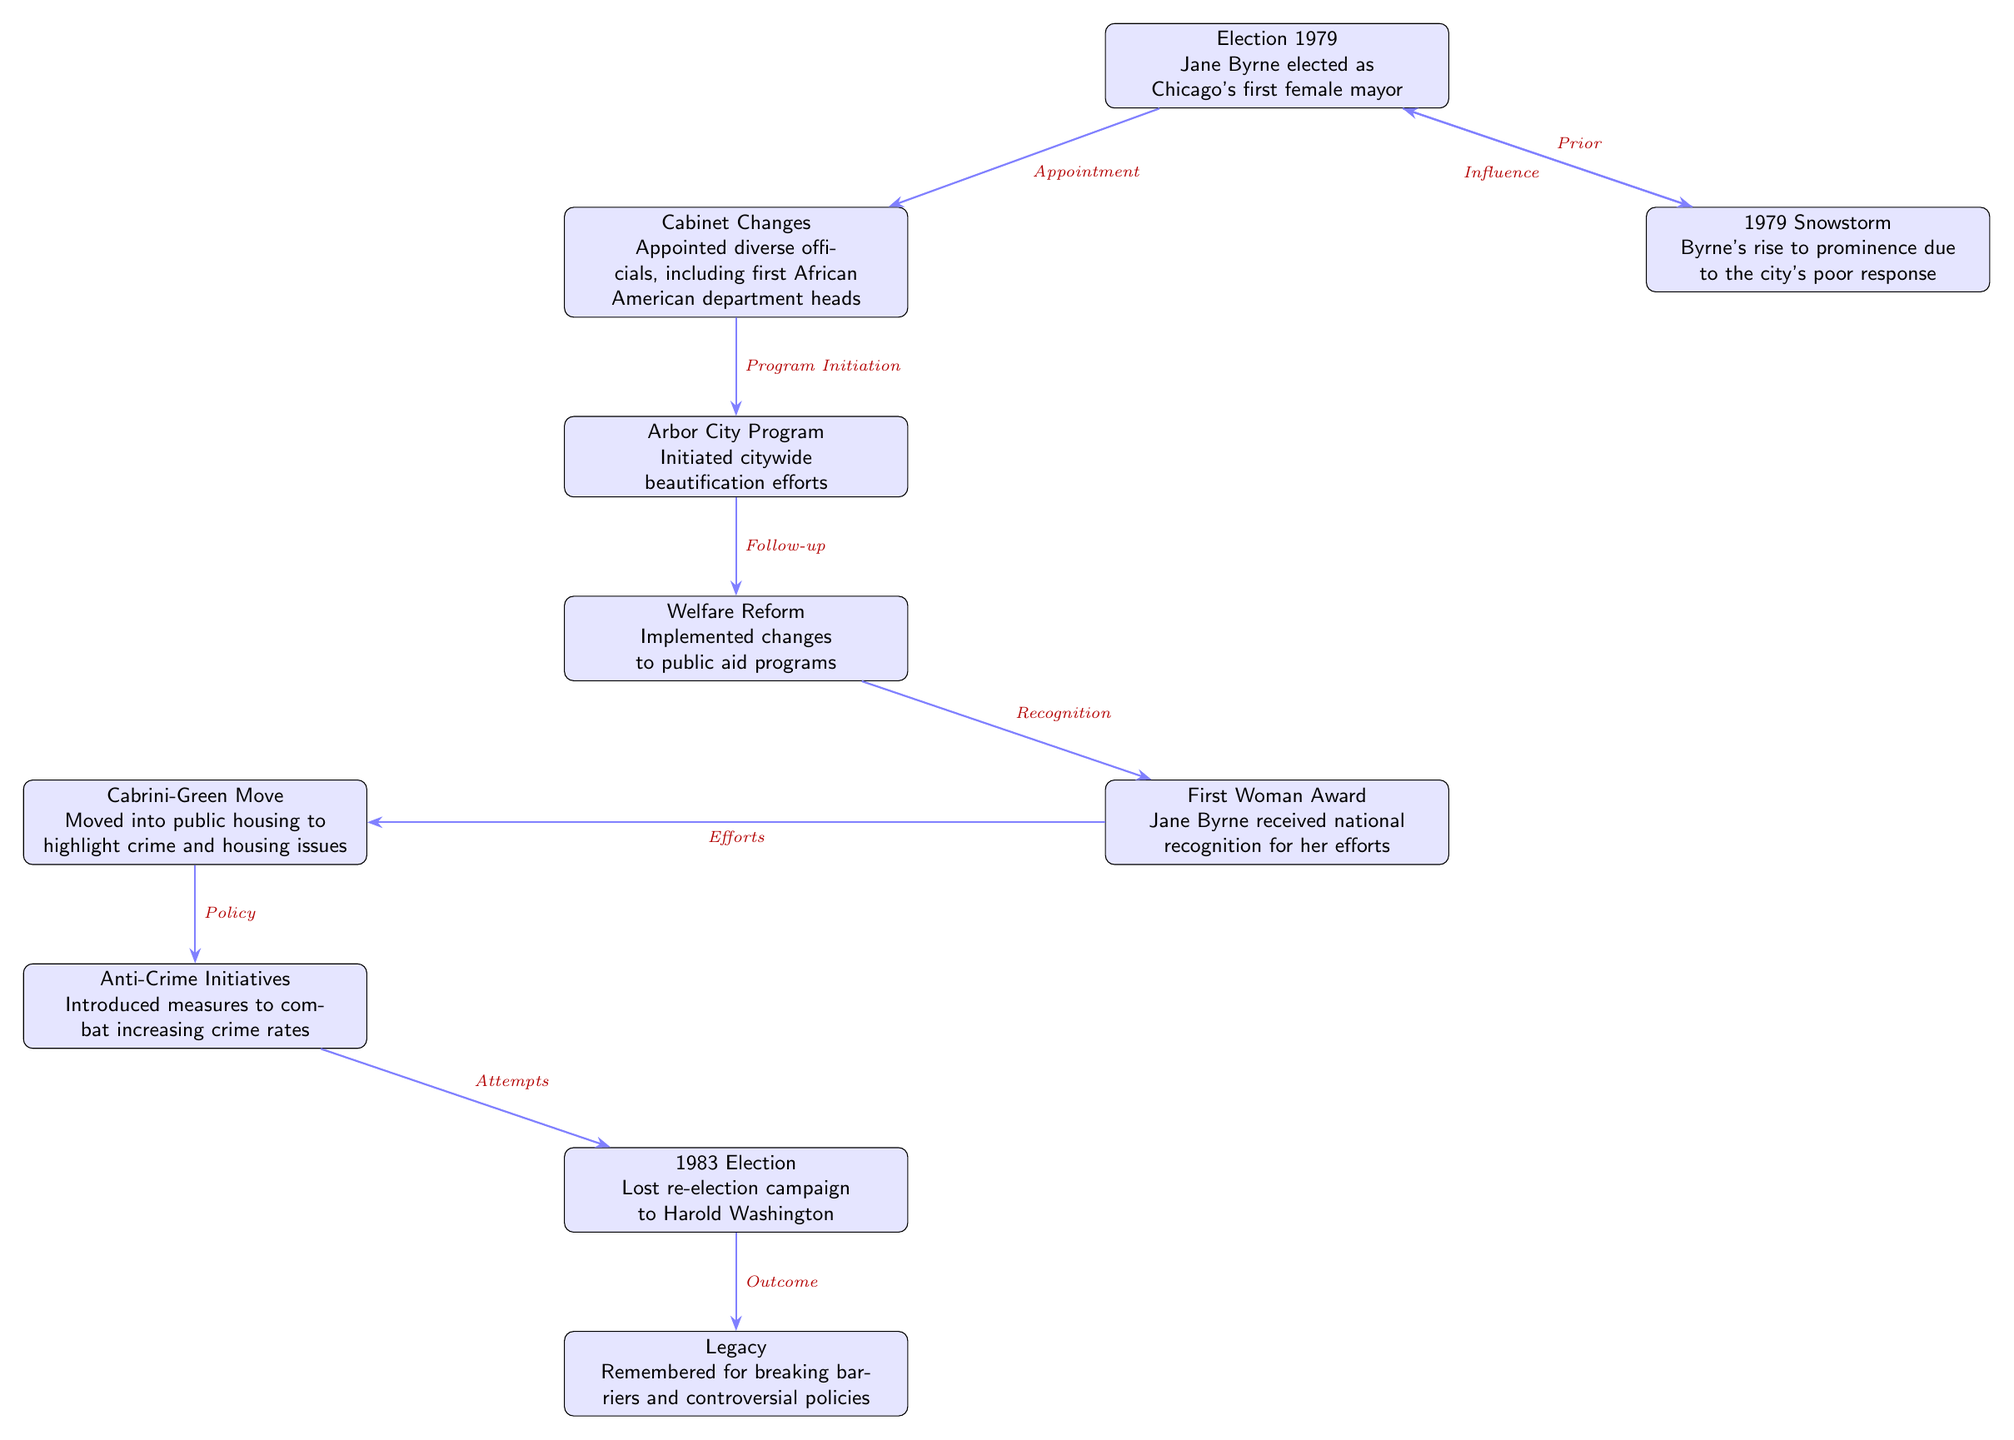What event marked Jane Byrne's election as mayor? The diagram indicates that Jane Byrne was elected as Chicago's first female mayor in 1979, which is the first event listed.
Answer: Chicago's first female mayor What happened after the snowstorm event? The diagram shows an arrow going from the snowstorm event to the election event, indicating that the poor response to the snowstorm influenced the election outcome.
Answer: Influence How many major events are listed during Jane Byrne's term? By counting the events in the diagram, there are a total of 9 major events outlined.
Answer: 9 What recognition did Jane Byrne receive during her term? The diagram mentions that she received the First Woman Award, which is an event outlined in the timeline.
Answer: First Woman Award Which initiative followed the cabinet changes? According to the diagram, the Arbor City Program was initiated following the cabinet changes, as indicated by the arrow leading downwards from the cabinet event.
Answer: Arbor City Program What is Jane Byrne's legacy characterized as? The final event in the diagram describes her legacy as remembered for breaking barriers and controversial policies.
Answer: Breaking barriers and controversial policies What did Jane Byrne do to highlight crime and housing issues? The diagram states that she moved into Cabrini-Green public housing to bring attention to these issues, as indicated by the corresponding event.
Answer: Moved into public housing What event is linked to the election in 1983? The diagram connects the Anti-Crime Initiatives event to the 1983 election, suggesting that her efforts in combating crime were a significant aspect leading to the election.
Answer: Anti-Crime Initiatives What type of officials did Byrne appoint during her cabinet changes? The diagram notes that she appointed diverse officials, including the first African American department heads, which is indicated in the cabinet changes event.
Answer: First African American department heads 